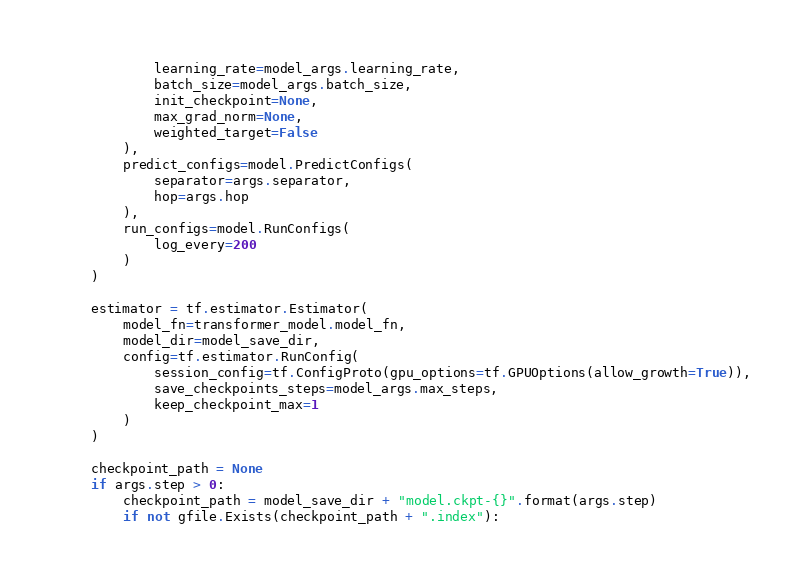<code> <loc_0><loc_0><loc_500><loc_500><_Python_>            learning_rate=model_args.learning_rate,
            batch_size=model_args.batch_size,
            init_checkpoint=None,
            max_grad_norm=None,
            weighted_target=False
        ),
        predict_configs=model.PredictConfigs(
            separator=args.separator,
            hop=args.hop
        ),
        run_configs=model.RunConfigs(
            log_every=200
        )
    )

    estimator = tf.estimator.Estimator(
        model_fn=transformer_model.model_fn,
        model_dir=model_save_dir,
        config=tf.estimator.RunConfig(
            session_config=tf.ConfigProto(gpu_options=tf.GPUOptions(allow_growth=True)),
            save_checkpoints_steps=model_args.max_steps,
            keep_checkpoint_max=1
        )
    )

    checkpoint_path = None
    if args.step > 0:
        checkpoint_path = model_save_dir + "model.ckpt-{}".format(args.step)
        if not gfile.Exists(checkpoint_path + ".index"):</code> 